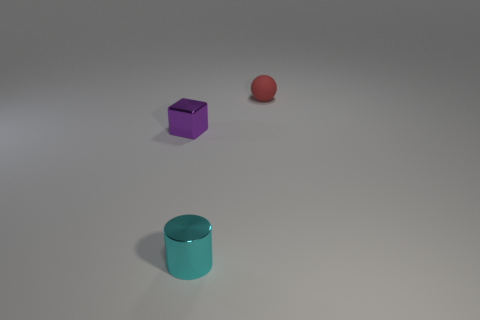What is the size of the object that is to the right of the thing that is in front of the small purple thing that is left of the cylinder?
Offer a very short reply. Small. What color is the tiny rubber thing behind the metallic thing that is left of the cylinder?
Provide a succinct answer. Red. How many other things are made of the same material as the red object?
Keep it short and to the point. 0. What number of other things are the same color as the small matte ball?
Keep it short and to the point. 0. What is the material of the small object that is in front of the small shiny object that is on the left side of the tiny cyan shiny thing?
Your response must be concise. Metal. Is there a large yellow metallic ball?
Provide a succinct answer. No. Are there more tiny shiny things behind the tiny cyan cylinder than cyan metal things that are on the right side of the ball?
Ensure brevity in your answer.  Yes. What number of spheres are purple things or matte things?
Provide a short and direct response. 1. There is a object that is on the left side of the cylinder; is it the same shape as the tiny cyan shiny thing?
Offer a very short reply. No. What color is the tiny shiny cube?
Offer a terse response. Purple. 